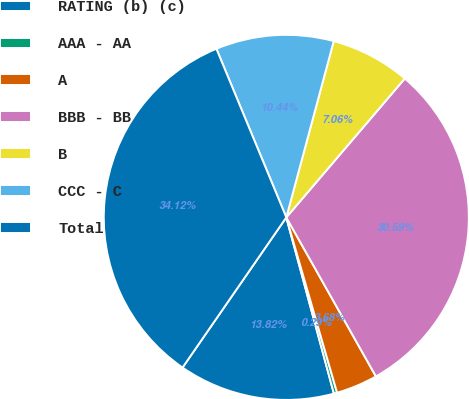<chart> <loc_0><loc_0><loc_500><loc_500><pie_chart><fcel>RATING (b) (c)<fcel>AAA - AA<fcel>A<fcel>BBB - BB<fcel>B<fcel>CCC - C<fcel>Total<nl><fcel>13.82%<fcel>0.29%<fcel>3.68%<fcel>30.59%<fcel>7.06%<fcel>10.44%<fcel>34.12%<nl></chart> 